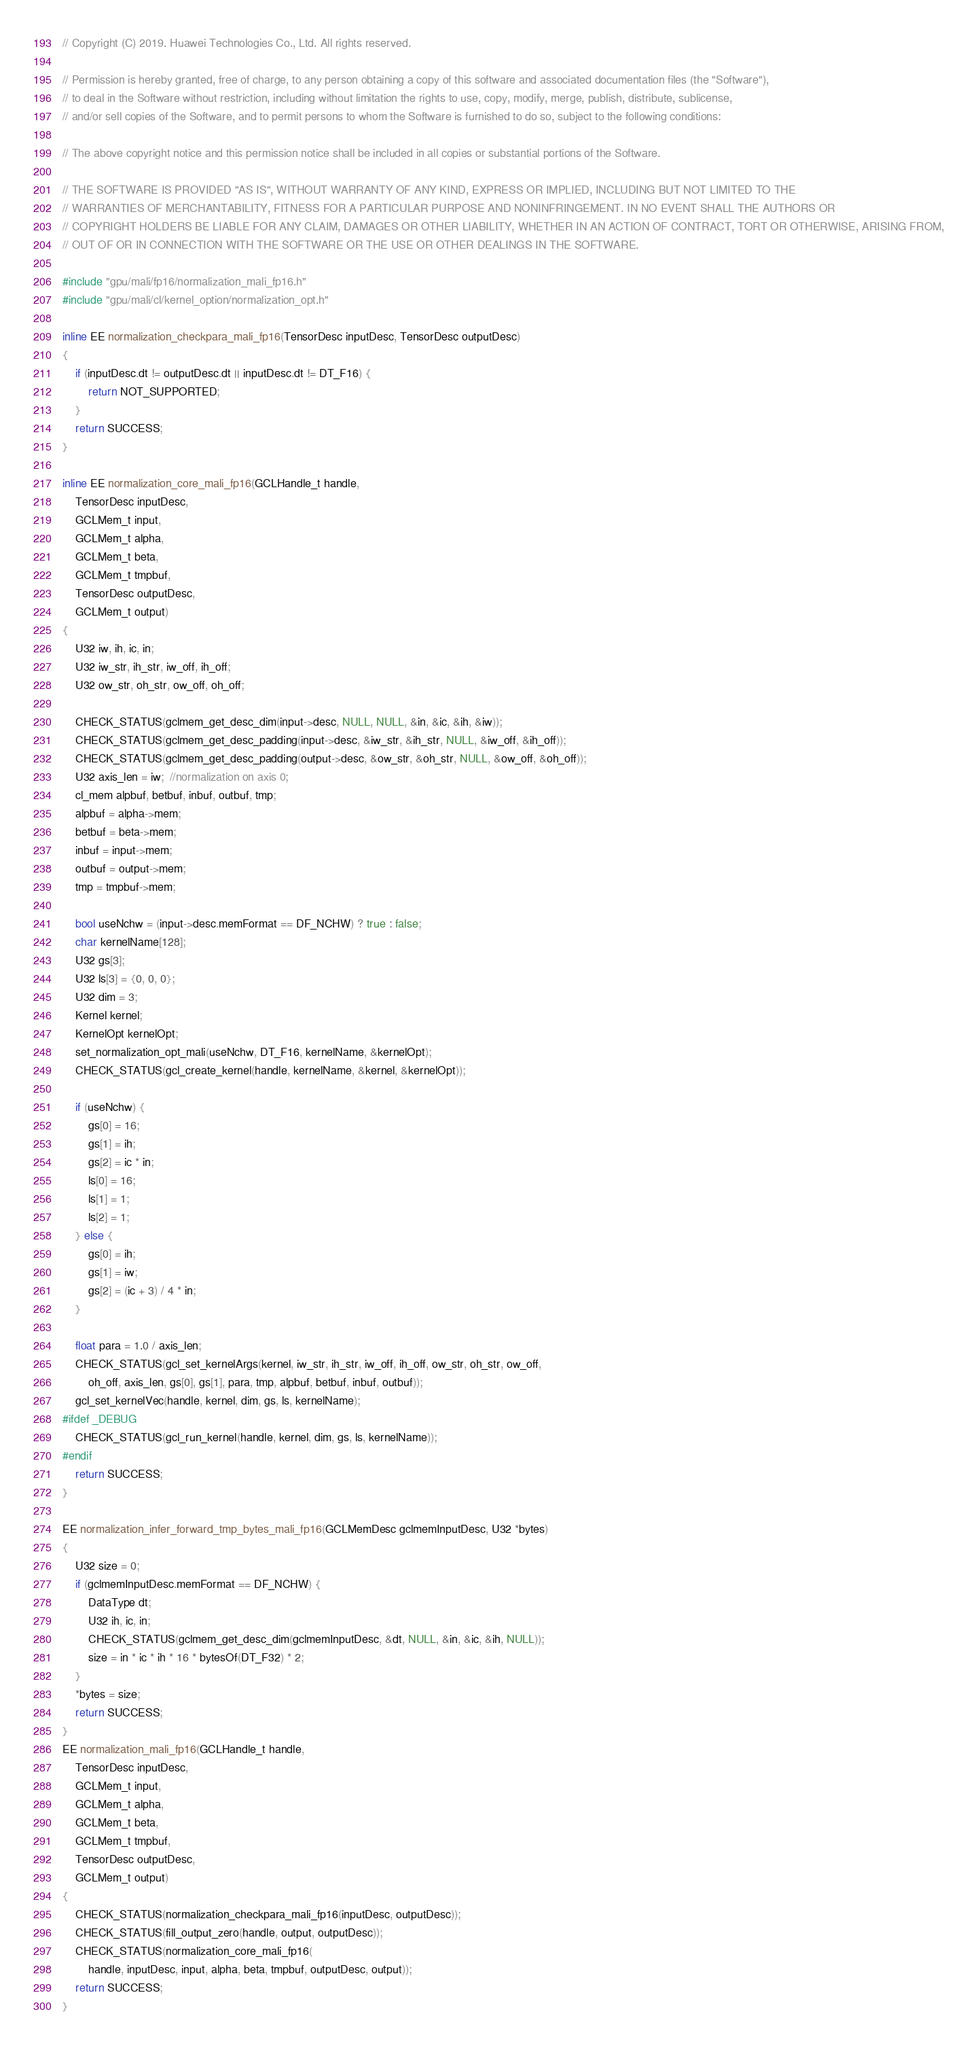Convert code to text. <code><loc_0><loc_0><loc_500><loc_500><_C++_>// Copyright (C) 2019. Huawei Technologies Co., Ltd. All rights reserved.

// Permission is hereby granted, free of charge, to any person obtaining a copy of this software and associated documentation files (the "Software"),
// to deal in the Software without restriction, including without limitation the rights to use, copy, modify, merge, publish, distribute, sublicense,
// and/or sell copies of the Software, and to permit persons to whom the Software is furnished to do so, subject to the following conditions:

// The above copyright notice and this permission notice shall be included in all copies or substantial portions of the Software.

// THE SOFTWARE IS PROVIDED "AS IS", WITHOUT WARRANTY OF ANY KIND, EXPRESS OR IMPLIED, INCLUDING BUT NOT LIMITED TO THE
// WARRANTIES OF MERCHANTABILITY, FITNESS FOR A PARTICULAR PURPOSE AND NONINFRINGEMENT. IN NO EVENT SHALL THE AUTHORS OR
// COPYRIGHT HOLDERS BE LIABLE FOR ANY CLAIM, DAMAGES OR OTHER LIABILITY, WHETHER IN AN ACTION OF CONTRACT, TORT OR OTHERWISE, ARISING FROM,
// OUT OF OR IN CONNECTION WITH THE SOFTWARE OR THE USE OR OTHER DEALINGS IN THE SOFTWARE.

#include "gpu/mali/fp16/normalization_mali_fp16.h"
#include "gpu/mali/cl/kernel_option/normalization_opt.h"

inline EE normalization_checkpara_mali_fp16(TensorDesc inputDesc, TensorDesc outputDesc)
{
    if (inputDesc.dt != outputDesc.dt || inputDesc.dt != DT_F16) {
        return NOT_SUPPORTED;
    }
    return SUCCESS;
}

inline EE normalization_core_mali_fp16(GCLHandle_t handle,
    TensorDesc inputDesc,
    GCLMem_t input,
    GCLMem_t alpha,
    GCLMem_t beta,
    GCLMem_t tmpbuf,
    TensorDesc outputDesc,
    GCLMem_t output)
{
    U32 iw, ih, ic, in;
    U32 iw_str, ih_str, iw_off, ih_off;
    U32 ow_str, oh_str, ow_off, oh_off;

    CHECK_STATUS(gclmem_get_desc_dim(input->desc, NULL, NULL, &in, &ic, &ih, &iw));
    CHECK_STATUS(gclmem_get_desc_padding(input->desc, &iw_str, &ih_str, NULL, &iw_off, &ih_off));
    CHECK_STATUS(gclmem_get_desc_padding(output->desc, &ow_str, &oh_str, NULL, &ow_off, &oh_off));
    U32 axis_len = iw;  //normalization on axis 0;
    cl_mem alpbuf, betbuf, inbuf, outbuf, tmp;
    alpbuf = alpha->mem;
    betbuf = beta->mem;
    inbuf = input->mem;
    outbuf = output->mem;
    tmp = tmpbuf->mem;

    bool useNchw = (input->desc.memFormat == DF_NCHW) ? true : false;
    char kernelName[128];
    U32 gs[3];
    U32 ls[3] = {0, 0, 0};
    U32 dim = 3;
    Kernel kernel;
    KernelOpt kernelOpt;
    set_normalization_opt_mali(useNchw, DT_F16, kernelName, &kernelOpt);
    CHECK_STATUS(gcl_create_kernel(handle, kernelName, &kernel, &kernelOpt));

    if (useNchw) {
        gs[0] = 16;
        gs[1] = ih;
        gs[2] = ic * in;
        ls[0] = 16;
        ls[1] = 1;
        ls[2] = 1;
    } else {
        gs[0] = ih;
        gs[1] = iw;
        gs[2] = (ic + 3) / 4 * in;
    }

    float para = 1.0 / axis_len;
    CHECK_STATUS(gcl_set_kernelArgs(kernel, iw_str, ih_str, iw_off, ih_off, ow_str, oh_str, ow_off,
        oh_off, axis_len, gs[0], gs[1], para, tmp, alpbuf, betbuf, inbuf, outbuf));
    gcl_set_kernelVec(handle, kernel, dim, gs, ls, kernelName);
#ifdef _DEBUG
    CHECK_STATUS(gcl_run_kernel(handle, kernel, dim, gs, ls, kernelName));
#endif
    return SUCCESS;
}

EE normalization_infer_forward_tmp_bytes_mali_fp16(GCLMemDesc gclmemInputDesc, U32 *bytes)
{
    U32 size = 0;
    if (gclmemInputDesc.memFormat == DF_NCHW) {
        DataType dt;
        U32 ih, ic, in;
        CHECK_STATUS(gclmem_get_desc_dim(gclmemInputDesc, &dt, NULL, &in, &ic, &ih, NULL));
        size = in * ic * ih * 16 * bytesOf(DT_F32) * 2;
    }
    *bytes = size;
    return SUCCESS;
}
EE normalization_mali_fp16(GCLHandle_t handle,
    TensorDesc inputDesc,
    GCLMem_t input,
    GCLMem_t alpha,
    GCLMem_t beta,
    GCLMem_t tmpbuf,
    TensorDesc outputDesc,
    GCLMem_t output)
{
    CHECK_STATUS(normalization_checkpara_mali_fp16(inputDesc, outputDesc));
    CHECK_STATUS(fill_output_zero(handle, output, outputDesc));
    CHECK_STATUS(normalization_core_mali_fp16(
        handle, inputDesc, input, alpha, beta, tmpbuf, outputDesc, output));
    return SUCCESS;
}
</code> 